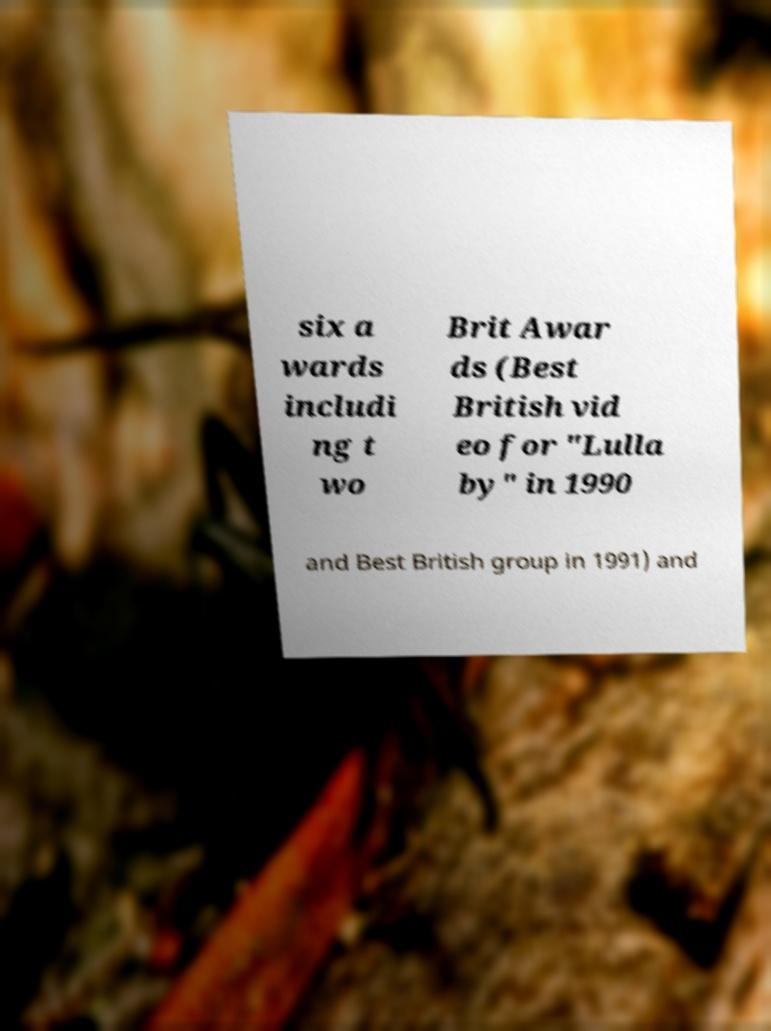What messages or text are displayed in this image? I need them in a readable, typed format. six a wards includi ng t wo Brit Awar ds (Best British vid eo for "Lulla by" in 1990 and Best British group in 1991) and 